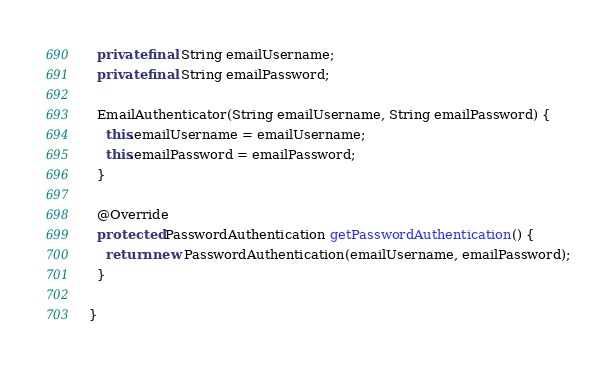<code> <loc_0><loc_0><loc_500><loc_500><_Java_>
  private final String emailUsername;
  private final String emailPassword;

  EmailAuthenticator(String emailUsername, String emailPassword) {
    this.emailUsername = emailUsername;
    this.emailPassword = emailPassword;
  }

  @Override
  protected PasswordAuthentication getPasswordAuthentication() {
    return new PasswordAuthentication(emailUsername, emailPassword);
  }

}
</code> 